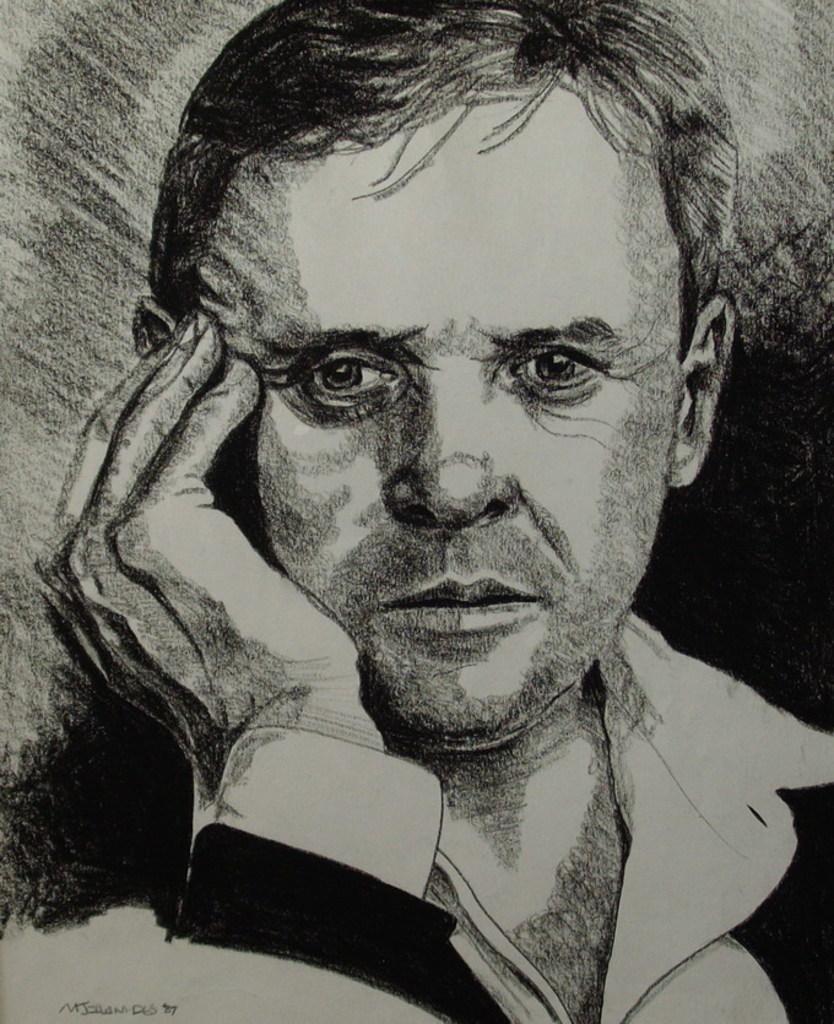How would you summarize this image in a sentence or two? In this image there is an art. In the art we can see there is a man who is keeping his hand on his face. 